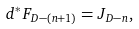<formula> <loc_0><loc_0><loc_500><loc_500>d ^ { * } F _ { D - ( n + 1 ) } = J _ { D - n } ,</formula> 